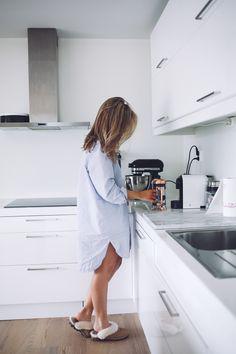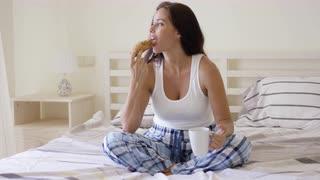The first image is the image on the left, the second image is the image on the right. Evaluate the accuracy of this statement regarding the images: "In one image a woman is sitting on a bed with her legs crossed and holding a beverage in a white cup.". Is it true? Answer yes or no. Yes. The first image is the image on the left, the second image is the image on the right. Analyze the images presented: Is the assertion "The left image contains a human sitting on a bed holding a coffee cup." valid? Answer yes or no. No. 